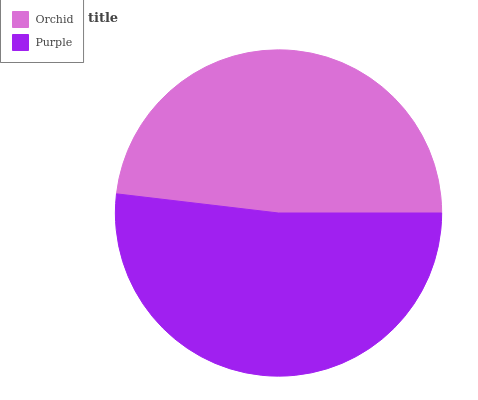Is Orchid the minimum?
Answer yes or no. Yes. Is Purple the maximum?
Answer yes or no. Yes. Is Purple the minimum?
Answer yes or no. No. Is Purple greater than Orchid?
Answer yes or no. Yes. Is Orchid less than Purple?
Answer yes or no. Yes. Is Orchid greater than Purple?
Answer yes or no. No. Is Purple less than Orchid?
Answer yes or no. No. Is Purple the high median?
Answer yes or no. Yes. Is Orchid the low median?
Answer yes or no. Yes. Is Orchid the high median?
Answer yes or no. No. Is Purple the low median?
Answer yes or no. No. 